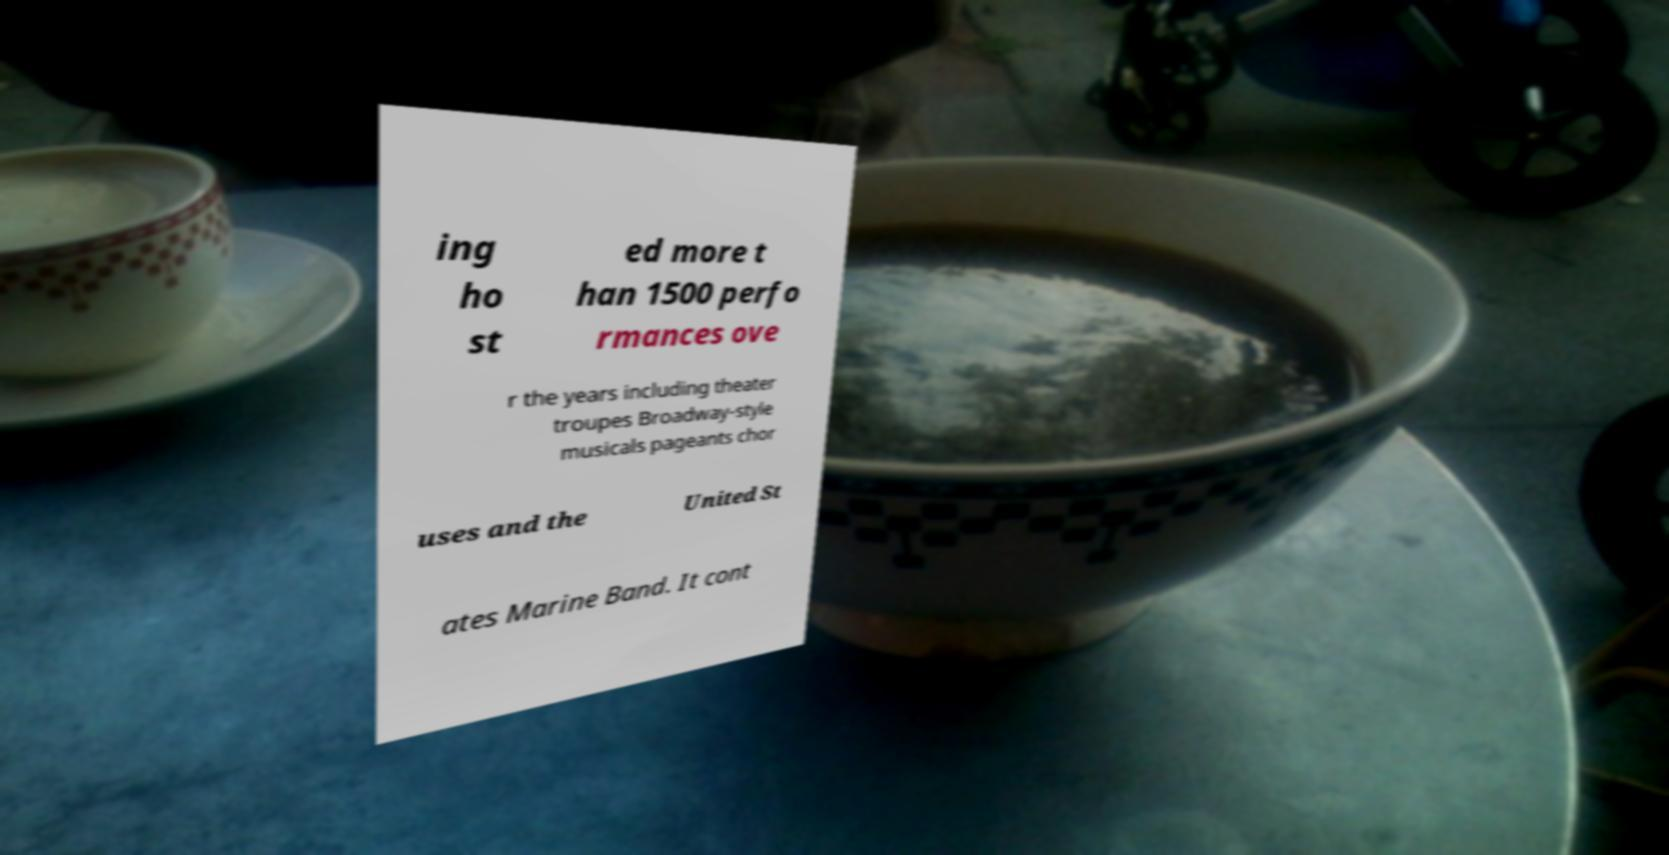For documentation purposes, I need the text within this image transcribed. Could you provide that? ing ho st ed more t han 1500 perfo rmances ove r the years including theater troupes Broadway-style musicals pageants chor uses and the United St ates Marine Band. It cont 